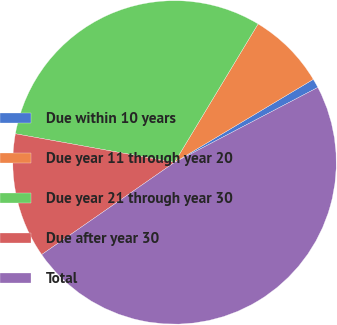Convert chart to OTSL. <chart><loc_0><loc_0><loc_500><loc_500><pie_chart><fcel>Due within 10 years<fcel>Due year 11 through year 20<fcel>Due year 21 through year 30<fcel>Due after year 30<fcel>Total<nl><fcel>0.91%<fcel>7.78%<fcel>30.81%<fcel>12.49%<fcel>48.02%<nl></chart> 